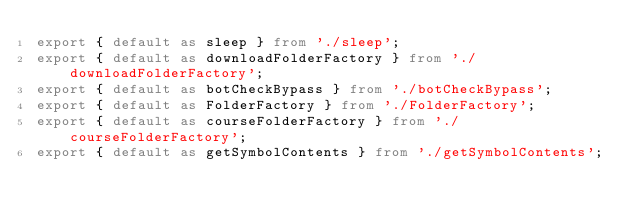Convert code to text. <code><loc_0><loc_0><loc_500><loc_500><_TypeScript_>export { default as sleep } from './sleep';
export { default as downloadFolderFactory } from './downloadFolderFactory';
export { default as botCheckBypass } from './botCheckBypass';
export { default as FolderFactory } from './FolderFactory';
export { default as courseFolderFactory } from './courseFolderFactory';
export { default as getSymbolContents } from './getSymbolContents';</code> 